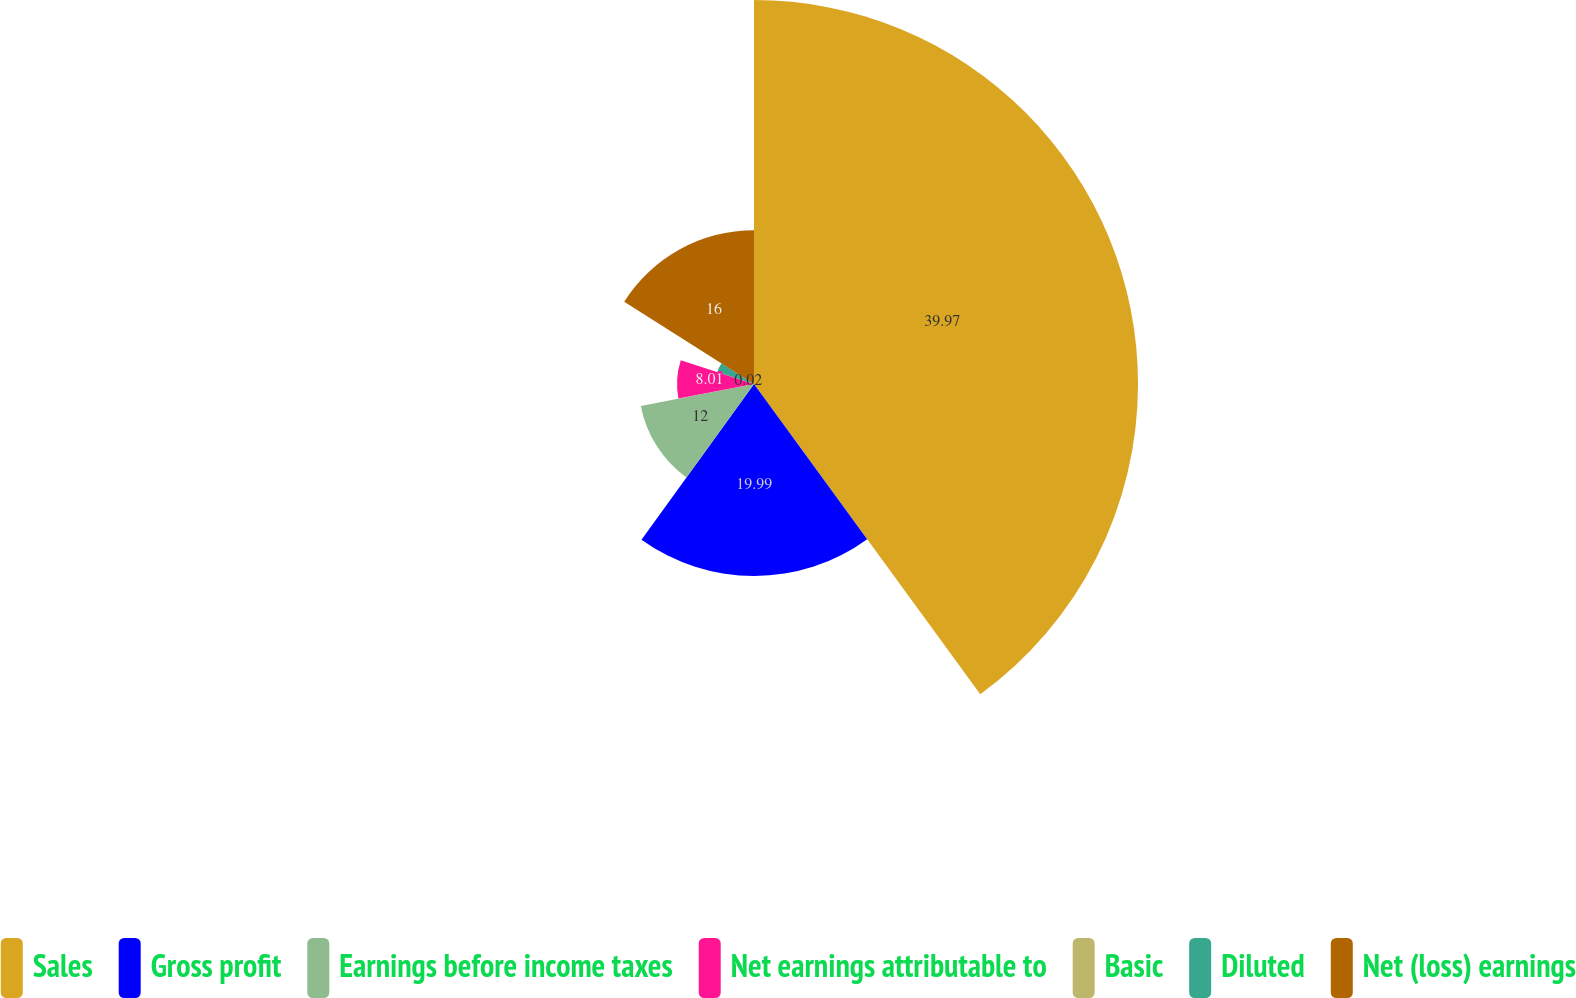<chart> <loc_0><loc_0><loc_500><loc_500><pie_chart><fcel>Sales<fcel>Gross profit<fcel>Earnings before income taxes<fcel>Net earnings attributable to<fcel>Basic<fcel>Diluted<fcel>Net (loss) earnings<nl><fcel>39.97%<fcel>19.99%<fcel>12.0%<fcel>8.01%<fcel>0.02%<fcel>4.01%<fcel>16.0%<nl></chart> 